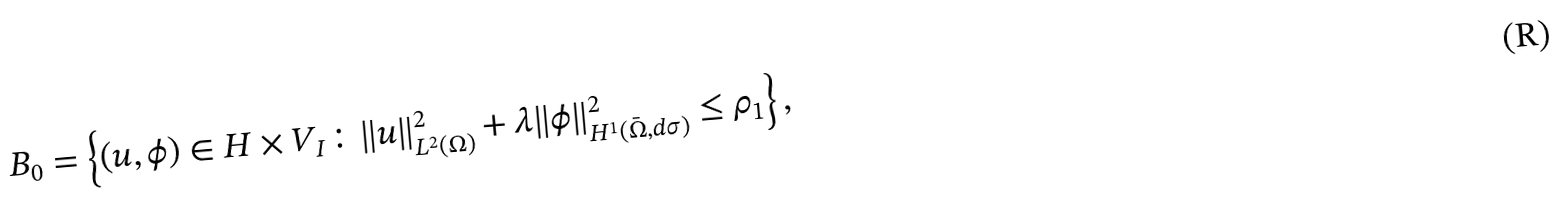Convert formula to latex. <formula><loc_0><loc_0><loc_500><loc_500>B _ { 0 } = \left \{ ( u , \phi ) \in H \times V _ { I } \colon \| u \| _ { L ^ { 2 } ( \Omega ) } ^ { 2 } + \lambda \| \phi \| _ { H ^ { 1 } ( \bar { \Omega } , d \sigma ) } ^ { 2 } \leq \rho _ { 1 } \right \} ,</formula> 